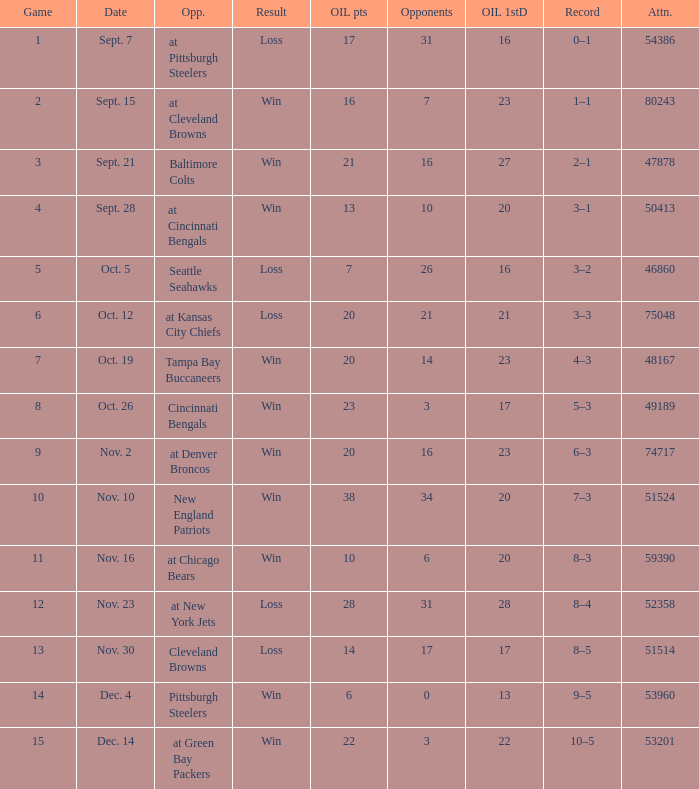What was the total opponents points for the game were the Oilers scored 21? 16.0. 